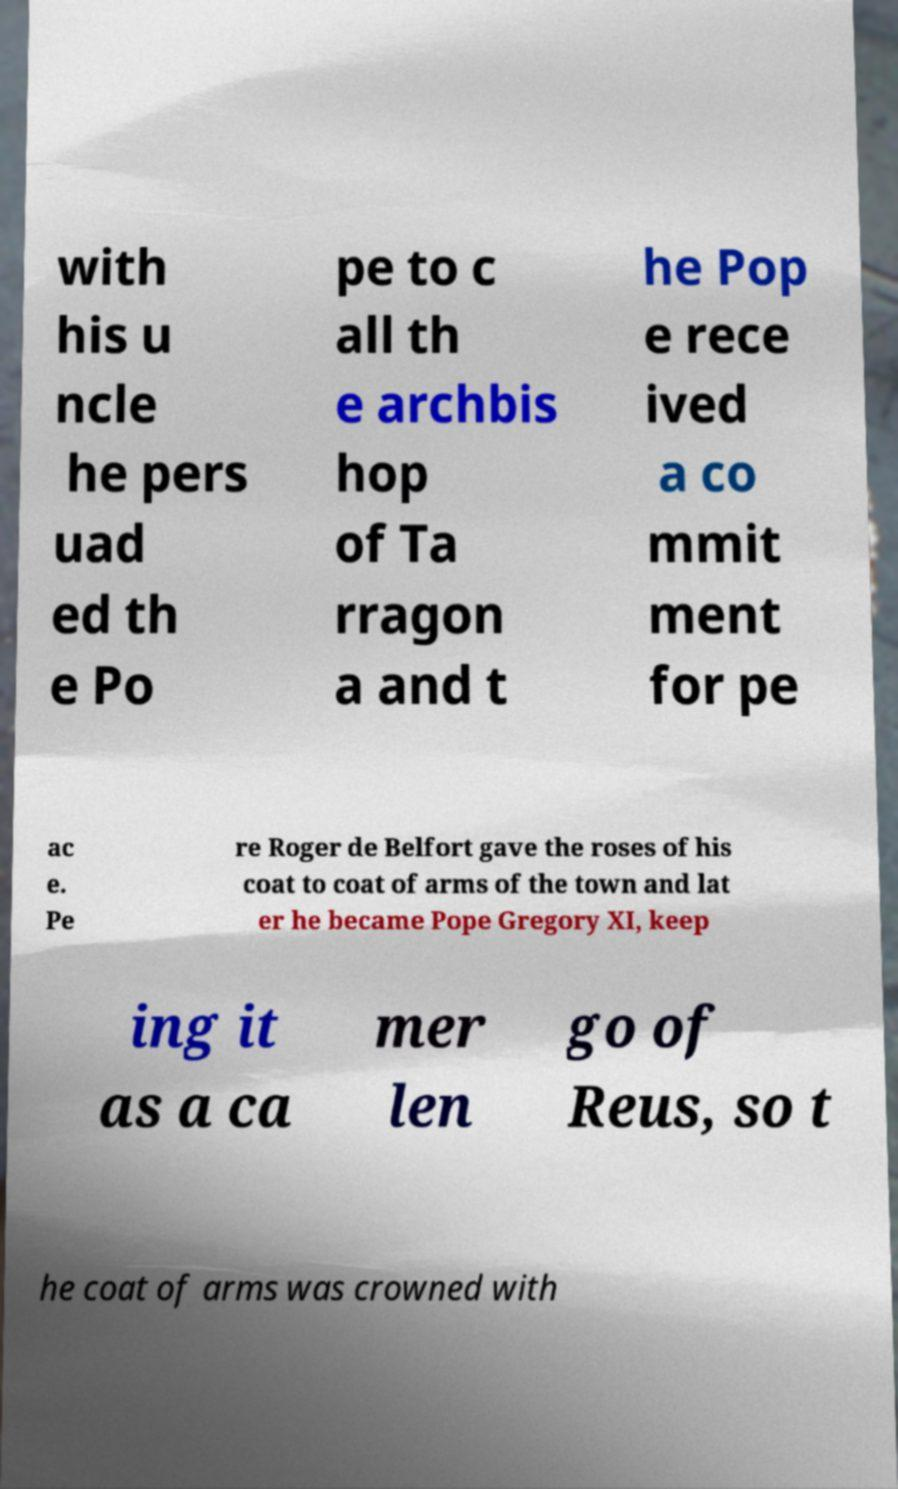I need the written content from this picture converted into text. Can you do that? with his u ncle he pers uad ed th e Po pe to c all th e archbis hop of Ta rragon a and t he Pop e rece ived a co mmit ment for pe ac e. Pe re Roger de Belfort gave the roses of his coat to coat of arms of the town and lat er he became Pope Gregory XI, keep ing it as a ca mer len go of Reus, so t he coat of arms was crowned with 